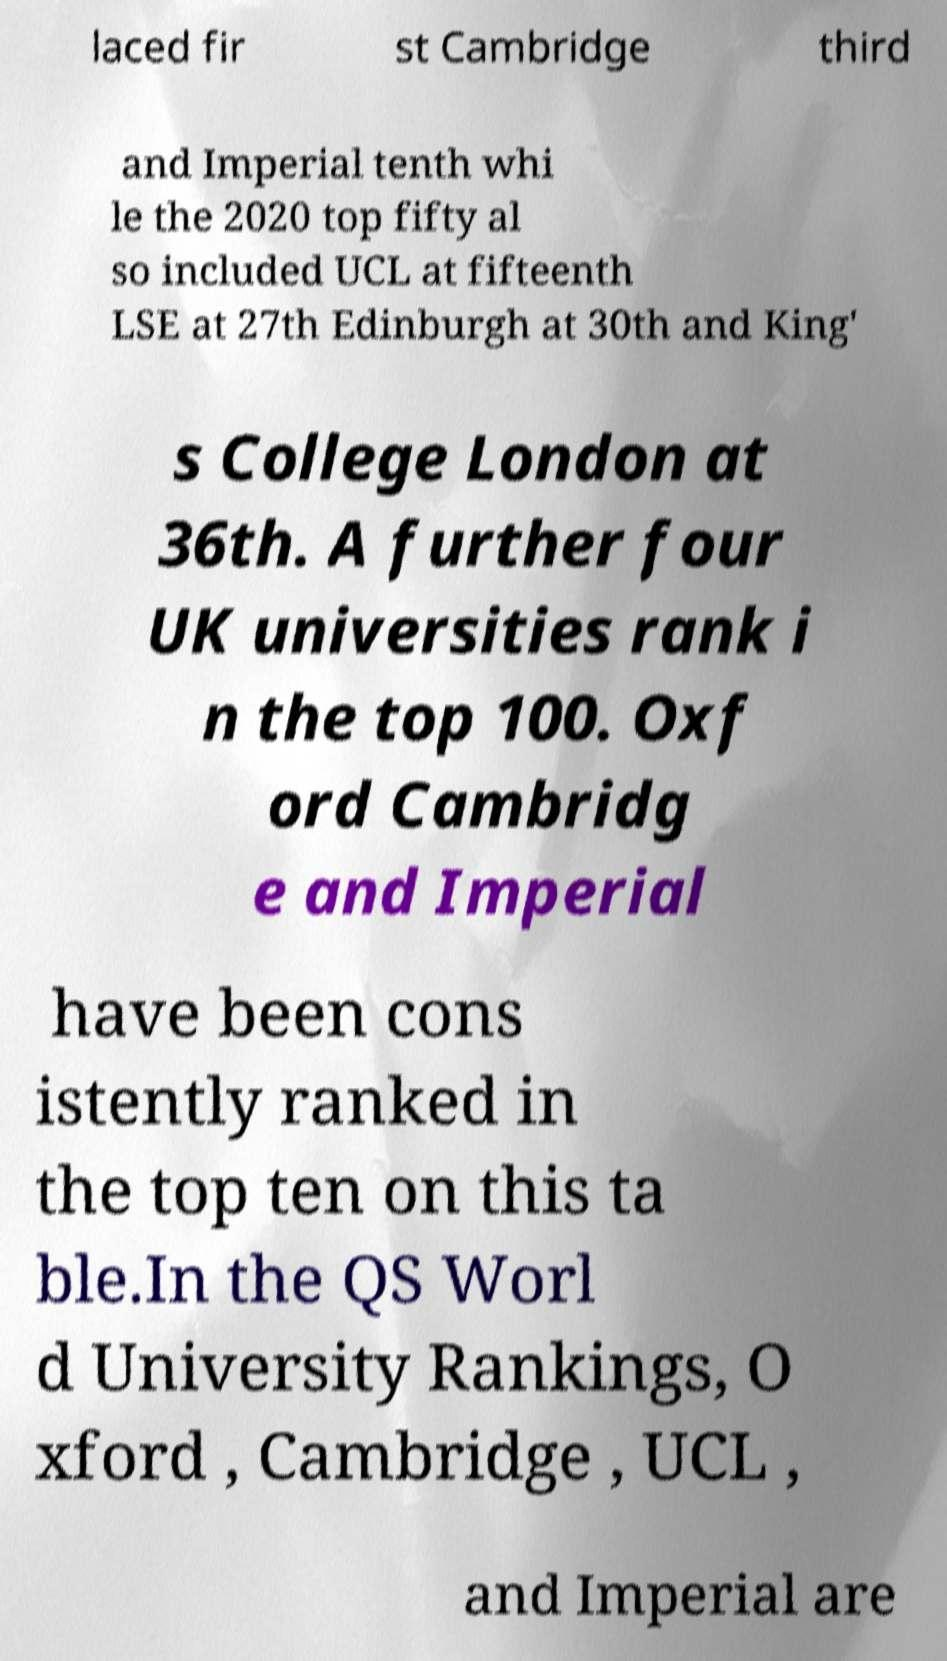Can you accurately transcribe the text from the provided image for me? laced fir st Cambridge third and Imperial tenth whi le the 2020 top fifty al so included UCL at fifteenth LSE at 27th Edinburgh at 30th and King' s College London at 36th. A further four UK universities rank i n the top 100. Oxf ord Cambridg e and Imperial have been cons istently ranked in the top ten on this ta ble.In the QS Worl d University Rankings, O xford , Cambridge , UCL , and Imperial are 